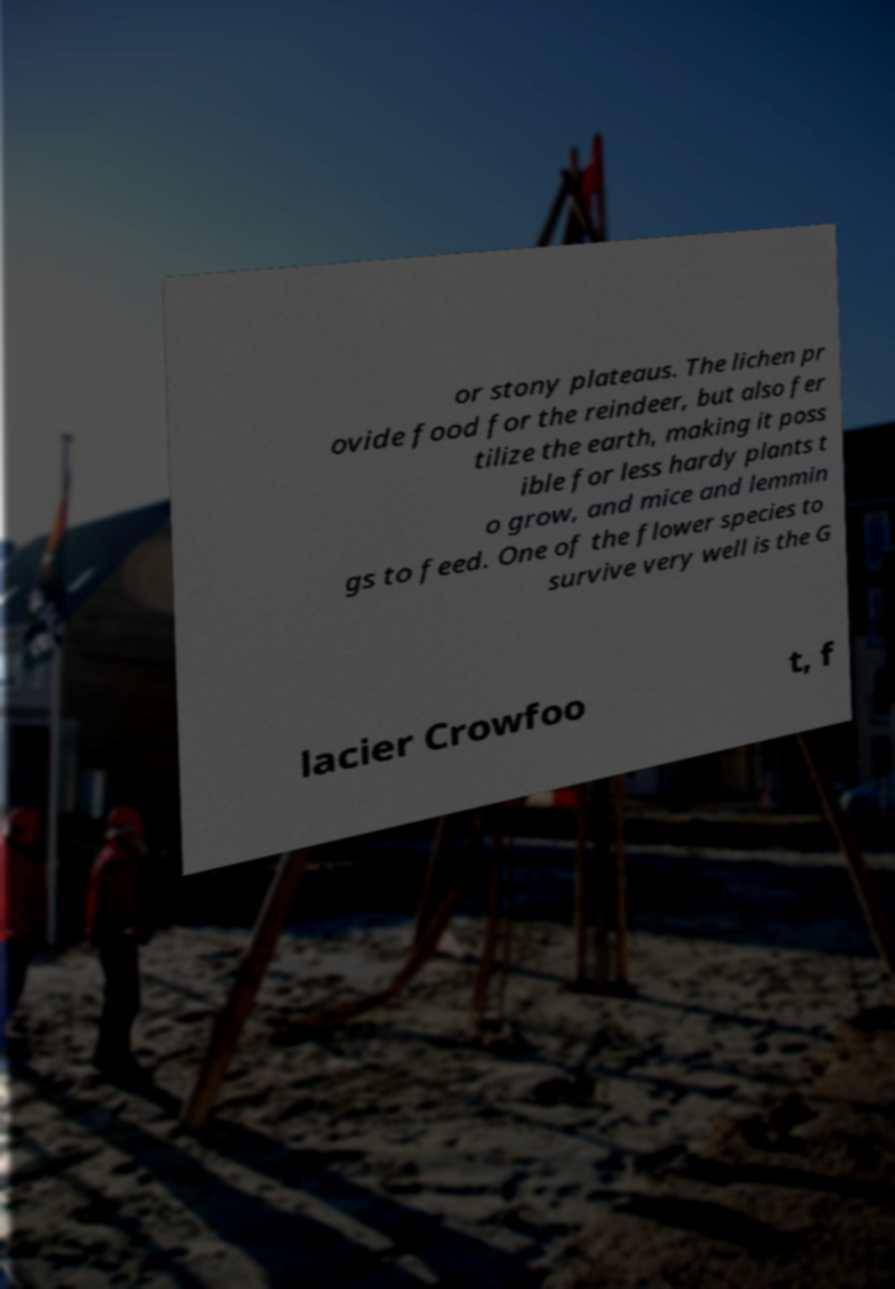What messages or text are displayed in this image? I need them in a readable, typed format. or stony plateaus. The lichen pr ovide food for the reindeer, but also fer tilize the earth, making it poss ible for less hardy plants t o grow, and mice and lemmin gs to feed. One of the flower species to survive very well is the G lacier Crowfoo t, f 